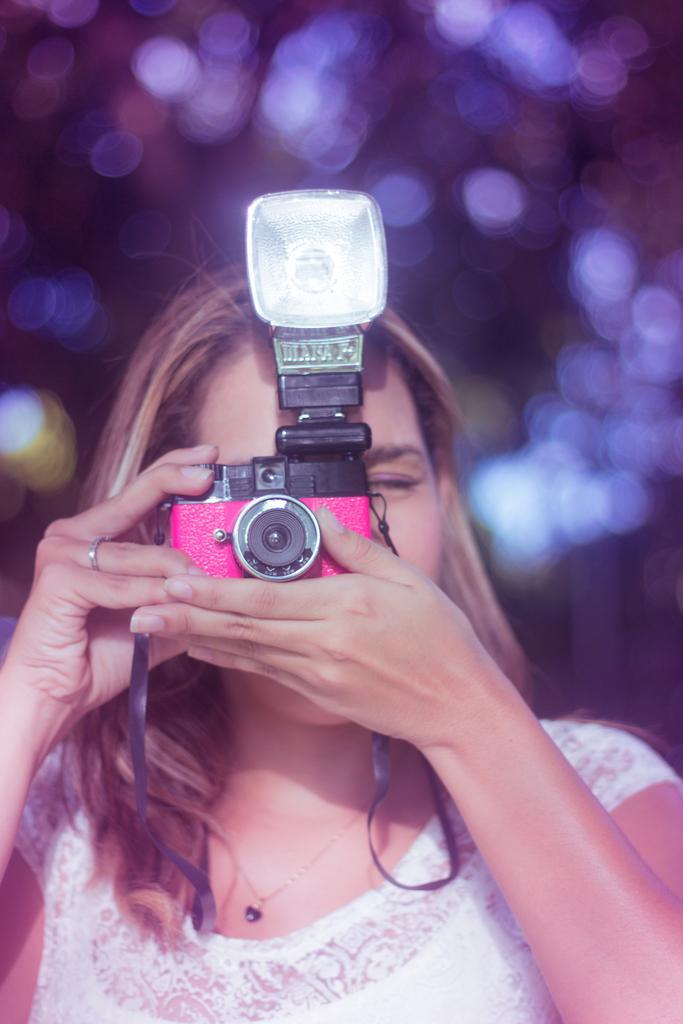In one or two sentences, can you explain what this image depicts? In this picture we can see woman holding camera with her hand and taking picture and in background it is blurry. 